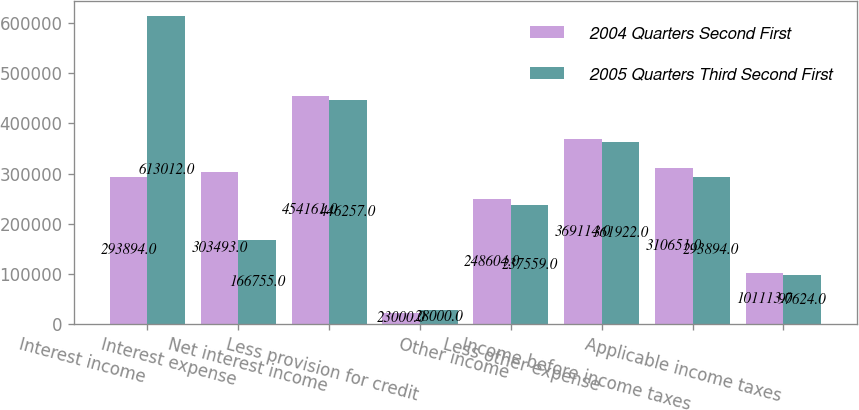Convert chart to OTSL. <chart><loc_0><loc_0><loc_500><loc_500><stacked_bar_chart><ecel><fcel>Interest income<fcel>Interest expense<fcel>Net interest income<fcel>Less provision for credit<fcel>Other income<fcel>Less other expense<fcel>Income before income taxes<fcel>Applicable income taxes<nl><fcel>2004 Quarters Second First<fcel>293894<fcel>303493<fcel>454161<fcel>23000<fcel>248604<fcel>369114<fcel>310651<fcel>101113<nl><fcel>2005 Quarters Third Second First<fcel>613012<fcel>166755<fcel>446257<fcel>28000<fcel>237559<fcel>361922<fcel>293894<fcel>97624<nl></chart> 